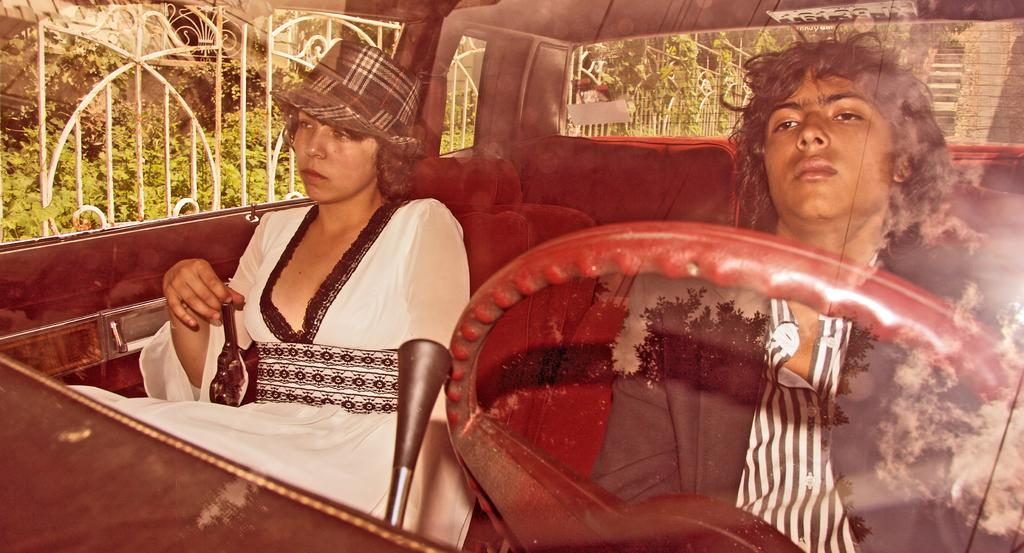How many people are in the car in the image? There are 2 people sitting in the car. What can be found in the front of the car? There is a steering wheel in the front of the car. What can be seen through the car windows? Fence and plants are visible through the car windows. What type of letters can be seen on the car's license plate in the image? There is no license plate visible in the image, so it is not possible to determine what type of letters might be present. 